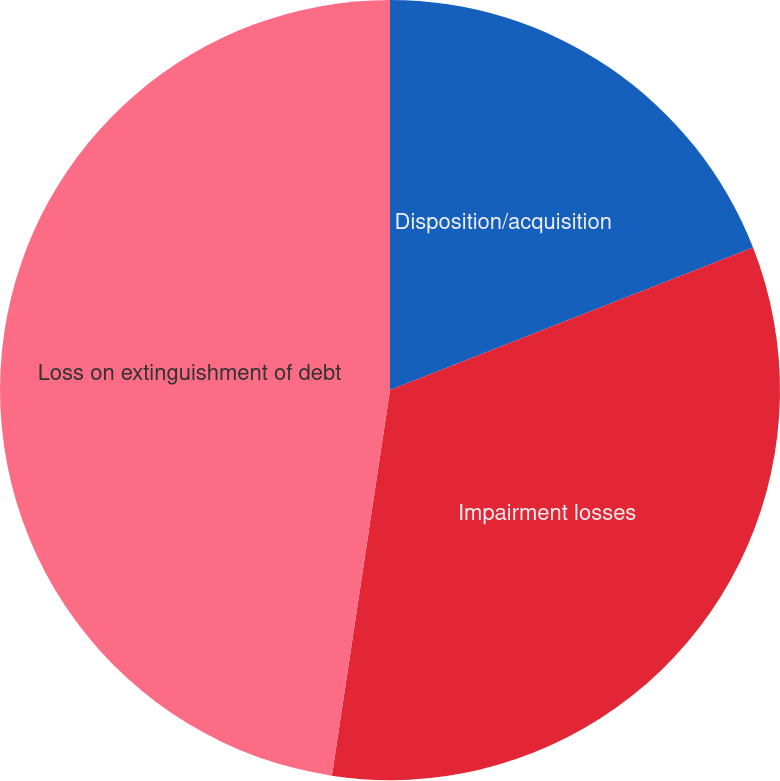<chart> <loc_0><loc_0><loc_500><loc_500><pie_chart><fcel>Disposition/acquisition<fcel>Impairment losses<fcel>Loss on extinguishment of debt<nl><fcel>19.05%<fcel>33.33%<fcel>47.62%<nl></chart> 